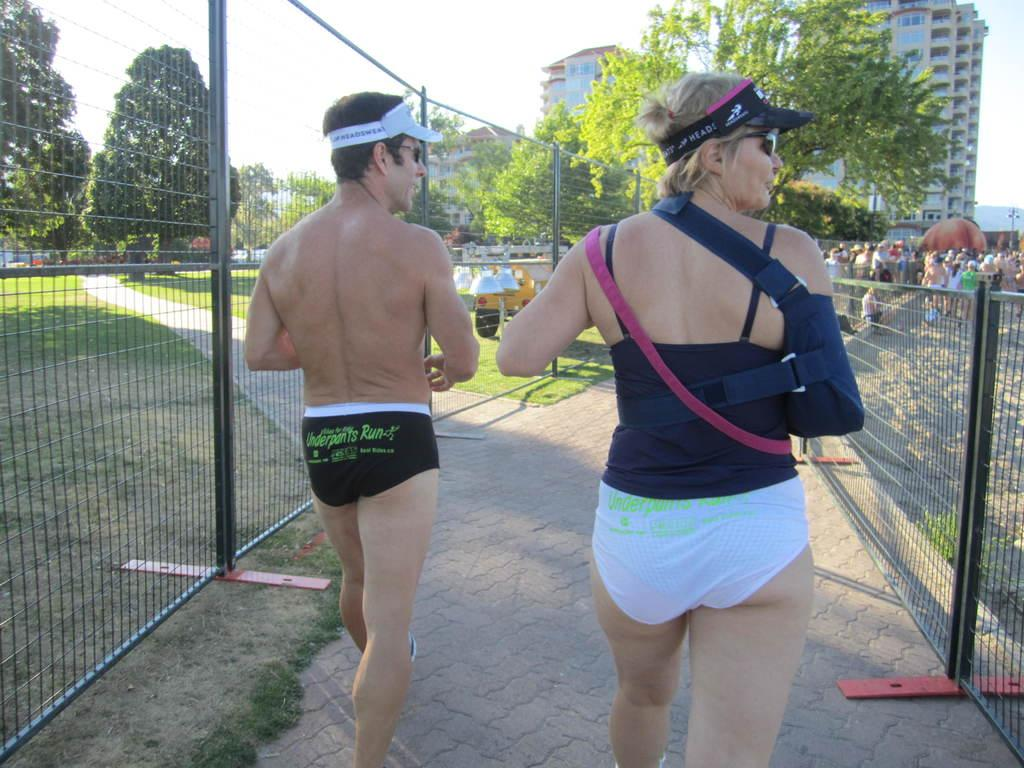Who can be seen in the image? There is a man and a woman in the image. What are they doing in the image? They are walking on a pathway. What can be seen in the background of the image? There are barricades, trees, and buildings in the image. Are there any other people in the image besides the man and woman? Yes, there are groups of people standing in the image. What type of spark can be seen coming from the houses in the image? There are no houses present in the image, and therefore no sparks can be seen. 